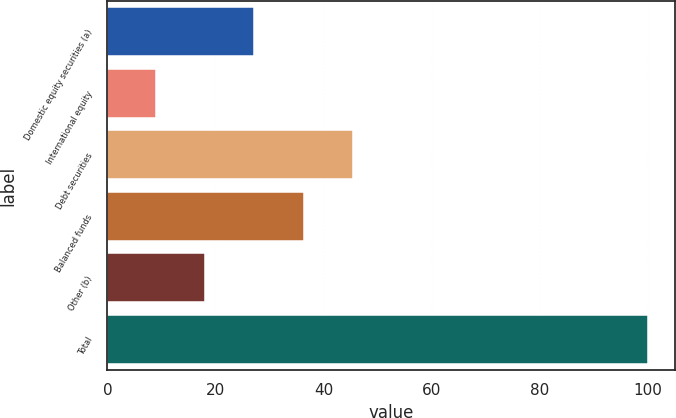<chart> <loc_0><loc_0><loc_500><loc_500><bar_chart><fcel>Domestic equity securities (a)<fcel>International equity<fcel>Debt securities<fcel>Balanced funds<fcel>Other (b)<fcel>Total<nl><fcel>27.2<fcel>9<fcel>45.4<fcel>36.3<fcel>18.1<fcel>100<nl></chart> 